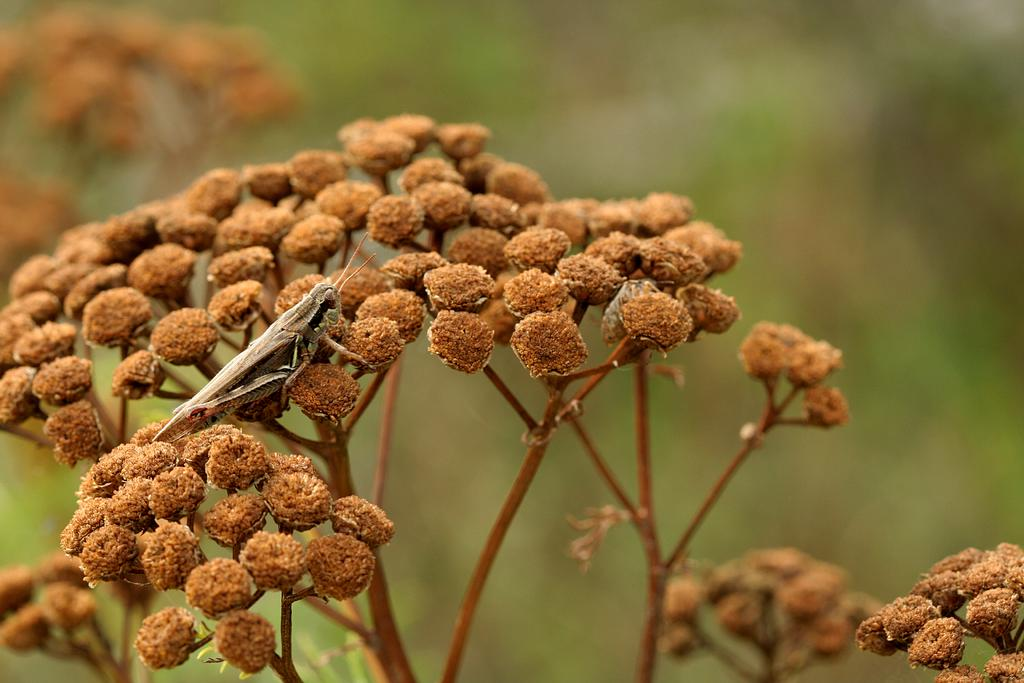What type of plant is in the image? There is a dried plant in the image. What can be seen on the dried plant? The dried plant has dried flowers on it. What other living organism is visible in the image? There is an insect visible in the image. How would you describe the background of the image? The background of the image is blurry. How does the plant pull itself towards the insect in the image? Plants do not have the ability to move or pull themselves towards insects; they are stationary organisms. 